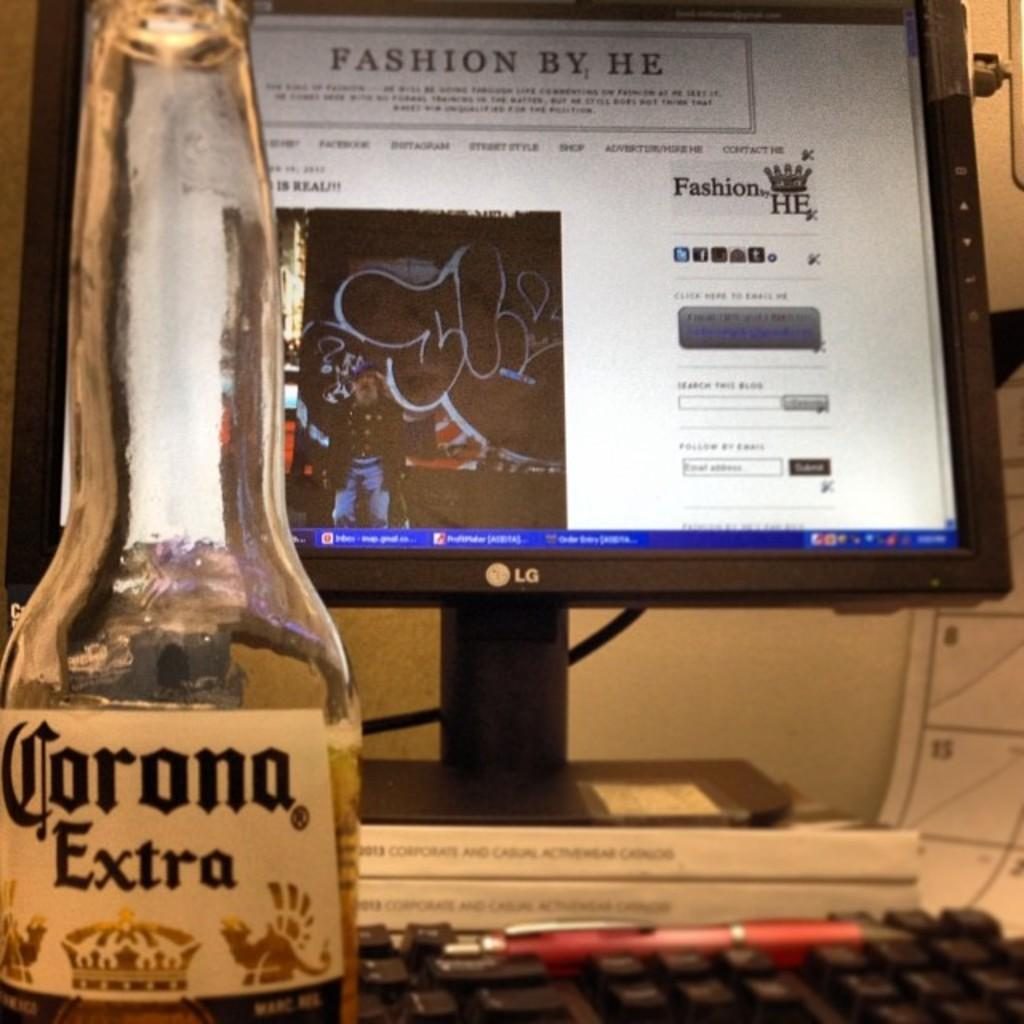<image>
Render a clear and concise summary of the photo. A bottle of Corona Extra is seen in front of a computer screen. 